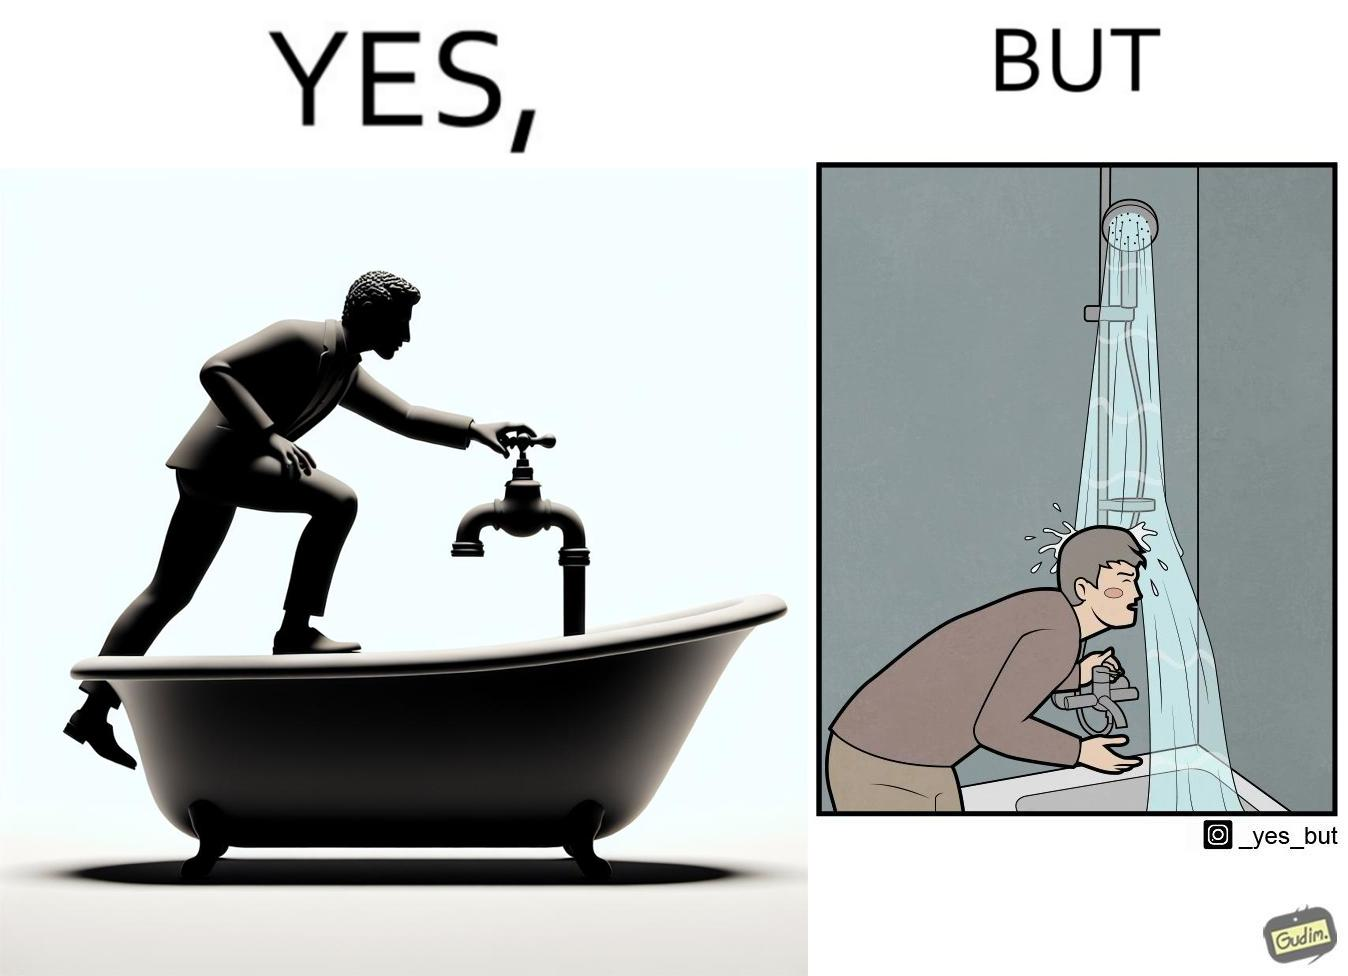Would you classify this image as satirical? Yes, this image is satirical. 